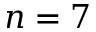<formula> <loc_0><loc_0><loc_500><loc_500>n = 7</formula> 